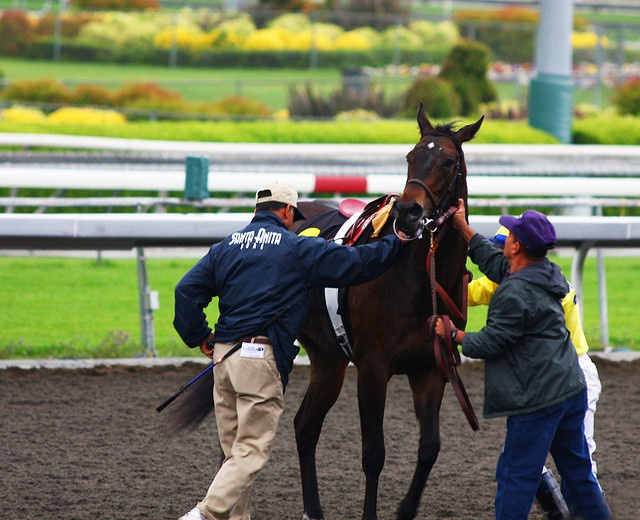Describe the objects in this image and their specific colors. I can see horse in green, black, gray, maroon, and lightgray tones, people in green, black, navy, tan, and gray tones, people in green, black, navy, gray, and blue tones, and people in green, white, khaki, gray, and gold tones in this image. 